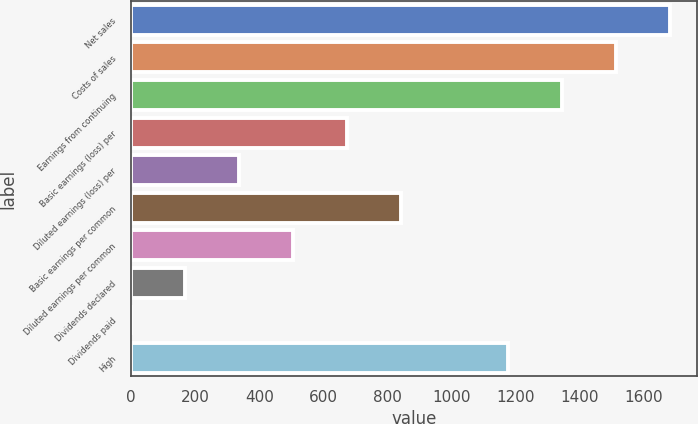<chart> <loc_0><loc_0><loc_500><loc_500><bar_chart><fcel>Net sales<fcel>Costs of sales<fcel>Earnings from continuing<fcel>Basic earnings (loss) per<fcel>Diluted earnings (loss) per<fcel>Basic earnings per common<fcel>Diluted earnings per common<fcel>Dividends declared<fcel>Dividends paid<fcel>High<nl><fcel>1682.04<fcel>1513.87<fcel>1345.7<fcel>673.02<fcel>336.68<fcel>841.19<fcel>504.85<fcel>168.51<fcel>0.34<fcel>1177.53<nl></chart> 